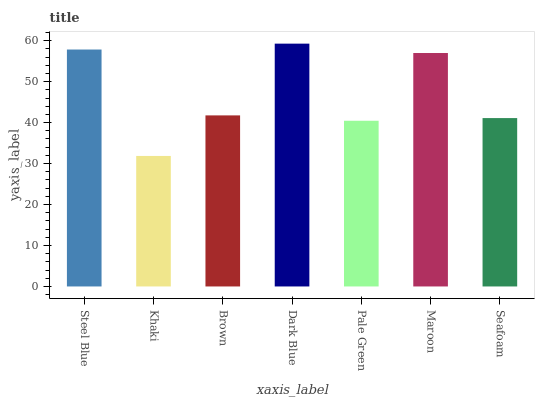Is Khaki the minimum?
Answer yes or no. Yes. Is Dark Blue the maximum?
Answer yes or no. Yes. Is Brown the minimum?
Answer yes or no. No. Is Brown the maximum?
Answer yes or no. No. Is Brown greater than Khaki?
Answer yes or no. Yes. Is Khaki less than Brown?
Answer yes or no. Yes. Is Khaki greater than Brown?
Answer yes or no. No. Is Brown less than Khaki?
Answer yes or no. No. Is Brown the high median?
Answer yes or no. Yes. Is Brown the low median?
Answer yes or no. Yes. Is Khaki the high median?
Answer yes or no. No. Is Steel Blue the low median?
Answer yes or no. No. 